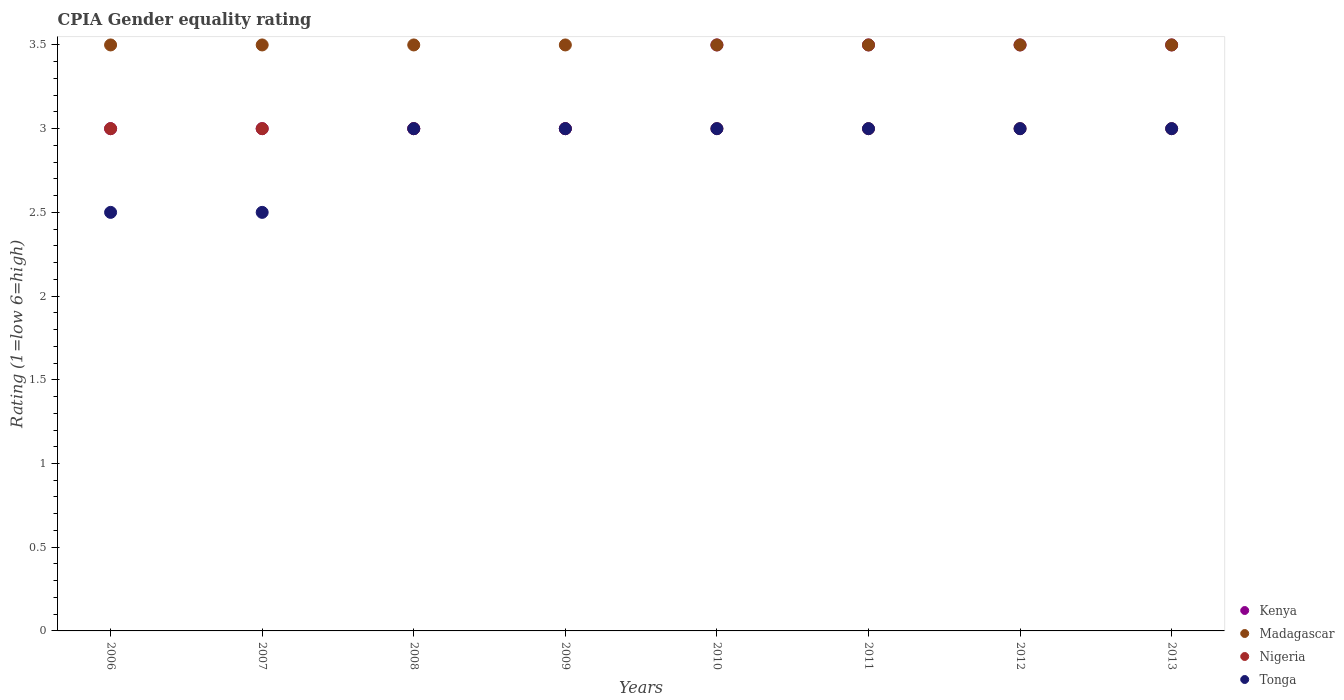How many different coloured dotlines are there?
Give a very brief answer. 4. Across all years, what is the maximum CPIA rating in Tonga?
Offer a very short reply. 3. Across all years, what is the minimum CPIA rating in Nigeria?
Offer a very short reply. 3. In which year was the CPIA rating in Tonga maximum?
Make the answer very short. 2008. What is the total CPIA rating in Tonga in the graph?
Provide a short and direct response. 23. What is the difference between the CPIA rating in Nigeria in 2007 and the CPIA rating in Madagascar in 2009?
Your answer should be compact. -0.5. In the year 2011, what is the difference between the CPIA rating in Nigeria and CPIA rating in Kenya?
Your answer should be very brief. -0.5. In how many years, is the CPIA rating in Kenya greater than 1.2?
Your answer should be very brief. 8. What is the ratio of the CPIA rating in Madagascar in 2011 to that in 2012?
Give a very brief answer. 1. Is the CPIA rating in Tonga in 2009 less than that in 2011?
Provide a succinct answer. No. What is the difference between the highest and the second highest CPIA rating in Kenya?
Offer a terse response. 0. What is the difference between the highest and the lowest CPIA rating in Tonga?
Your answer should be compact. 0.5. Is the sum of the CPIA rating in Tonga in 2006 and 2009 greater than the maximum CPIA rating in Madagascar across all years?
Offer a very short reply. Yes. Is it the case that in every year, the sum of the CPIA rating in Nigeria and CPIA rating in Tonga  is greater than the sum of CPIA rating in Madagascar and CPIA rating in Kenya?
Your answer should be compact. No. Is it the case that in every year, the sum of the CPIA rating in Kenya and CPIA rating in Madagascar  is greater than the CPIA rating in Tonga?
Ensure brevity in your answer.  Yes. Does the CPIA rating in Tonga monotonically increase over the years?
Offer a very short reply. No. What is the difference between two consecutive major ticks on the Y-axis?
Your answer should be compact. 0.5. Where does the legend appear in the graph?
Give a very brief answer. Bottom right. What is the title of the graph?
Provide a short and direct response. CPIA Gender equality rating. What is the label or title of the X-axis?
Provide a succinct answer. Years. What is the label or title of the Y-axis?
Ensure brevity in your answer.  Rating (1=low 6=high). What is the Rating (1=low 6=high) of Kenya in 2006?
Offer a very short reply. 3. What is the Rating (1=low 6=high) of Kenya in 2007?
Keep it short and to the point. 3. What is the Rating (1=low 6=high) in Madagascar in 2007?
Make the answer very short. 3.5. What is the Rating (1=low 6=high) of Nigeria in 2007?
Provide a short and direct response. 3. What is the Rating (1=low 6=high) of Madagascar in 2008?
Offer a very short reply. 3.5. What is the Rating (1=low 6=high) in Nigeria in 2008?
Make the answer very short. 3. What is the Rating (1=low 6=high) in Nigeria in 2009?
Give a very brief answer. 3. What is the Rating (1=low 6=high) in Tonga in 2009?
Your answer should be compact. 3. What is the Rating (1=low 6=high) of Nigeria in 2010?
Provide a short and direct response. 3. What is the Rating (1=low 6=high) of Kenya in 2011?
Give a very brief answer. 3.5. What is the Rating (1=low 6=high) of Tonga in 2011?
Provide a short and direct response. 3. What is the Rating (1=low 6=high) in Kenya in 2013?
Your response must be concise. 3.5. What is the Rating (1=low 6=high) in Nigeria in 2013?
Offer a very short reply. 3. What is the Rating (1=low 6=high) in Tonga in 2013?
Provide a succinct answer. 3. Across all years, what is the maximum Rating (1=low 6=high) in Madagascar?
Keep it short and to the point. 3.5. Across all years, what is the maximum Rating (1=low 6=high) of Tonga?
Keep it short and to the point. 3. Across all years, what is the minimum Rating (1=low 6=high) in Kenya?
Offer a terse response. 3. Across all years, what is the minimum Rating (1=low 6=high) of Madagascar?
Your answer should be compact. 3.5. What is the total Rating (1=low 6=high) in Kenya in the graph?
Offer a very short reply. 26. What is the total Rating (1=low 6=high) in Tonga in the graph?
Your answer should be very brief. 23. What is the difference between the Rating (1=low 6=high) in Madagascar in 2006 and that in 2007?
Make the answer very short. 0. What is the difference between the Rating (1=low 6=high) of Nigeria in 2006 and that in 2007?
Keep it short and to the point. 0. What is the difference between the Rating (1=low 6=high) of Tonga in 2006 and that in 2008?
Provide a short and direct response. -0.5. What is the difference between the Rating (1=low 6=high) of Kenya in 2006 and that in 2009?
Give a very brief answer. 0. What is the difference between the Rating (1=low 6=high) in Nigeria in 2006 and that in 2009?
Offer a terse response. 0. What is the difference between the Rating (1=low 6=high) of Kenya in 2006 and that in 2010?
Make the answer very short. -0.5. What is the difference between the Rating (1=low 6=high) in Madagascar in 2006 and that in 2010?
Ensure brevity in your answer.  0. What is the difference between the Rating (1=low 6=high) of Kenya in 2006 and that in 2011?
Your response must be concise. -0.5. What is the difference between the Rating (1=low 6=high) of Nigeria in 2006 and that in 2011?
Provide a short and direct response. 0. What is the difference between the Rating (1=low 6=high) in Kenya in 2006 and that in 2012?
Give a very brief answer. -0.5. What is the difference between the Rating (1=low 6=high) in Tonga in 2006 and that in 2012?
Keep it short and to the point. -0.5. What is the difference between the Rating (1=low 6=high) of Madagascar in 2006 and that in 2013?
Your answer should be very brief. 0. What is the difference between the Rating (1=low 6=high) of Tonga in 2006 and that in 2013?
Make the answer very short. -0.5. What is the difference between the Rating (1=low 6=high) of Tonga in 2007 and that in 2008?
Give a very brief answer. -0.5. What is the difference between the Rating (1=low 6=high) of Kenya in 2007 and that in 2009?
Give a very brief answer. 0. What is the difference between the Rating (1=low 6=high) in Tonga in 2007 and that in 2009?
Ensure brevity in your answer.  -0.5. What is the difference between the Rating (1=low 6=high) in Nigeria in 2007 and that in 2010?
Offer a terse response. 0. What is the difference between the Rating (1=low 6=high) of Madagascar in 2007 and that in 2011?
Offer a terse response. 0. What is the difference between the Rating (1=low 6=high) in Nigeria in 2007 and that in 2011?
Make the answer very short. 0. What is the difference between the Rating (1=low 6=high) in Tonga in 2007 and that in 2011?
Your answer should be very brief. -0.5. What is the difference between the Rating (1=low 6=high) in Kenya in 2007 and that in 2012?
Ensure brevity in your answer.  -0.5. What is the difference between the Rating (1=low 6=high) of Tonga in 2007 and that in 2013?
Ensure brevity in your answer.  -0.5. What is the difference between the Rating (1=low 6=high) in Kenya in 2008 and that in 2009?
Provide a succinct answer. 0. What is the difference between the Rating (1=low 6=high) of Madagascar in 2008 and that in 2009?
Your response must be concise. 0. What is the difference between the Rating (1=low 6=high) in Nigeria in 2008 and that in 2009?
Ensure brevity in your answer.  0. What is the difference between the Rating (1=low 6=high) in Madagascar in 2008 and that in 2010?
Your response must be concise. 0. What is the difference between the Rating (1=low 6=high) in Tonga in 2008 and that in 2010?
Give a very brief answer. 0. What is the difference between the Rating (1=low 6=high) of Madagascar in 2008 and that in 2011?
Give a very brief answer. 0. What is the difference between the Rating (1=low 6=high) in Nigeria in 2008 and that in 2011?
Offer a very short reply. 0. What is the difference between the Rating (1=low 6=high) of Tonga in 2008 and that in 2011?
Offer a terse response. 0. What is the difference between the Rating (1=low 6=high) of Nigeria in 2008 and that in 2012?
Give a very brief answer. 0. What is the difference between the Rating (1=low 6=high) in Kenya in 2008 and that in 2013?
Make the answer very short. -0.5. What is the difference between the Rating (1=low 6=high) of Madagascar in 2008 and that in 2013?
Offer a very short reply. 0. What is the difference between the Rating (1=low 6=high) in Nigeria in 2008 and that in 2013?
Ensure brevity in your answer.  0. What is the difference between the Rating (1=low 6=high) in Nigeria in 2009 and that in 2010?
Offer a terse response. 0. What is the difference between the Rating (1=low 6=high) in Kenya in 2009 and that in 2011?
Make the answer very short. -0.5. What is the difference between the Rating (1=low 6=high) of Nigeria in 2009 and that in 2012?
Ensure brevity in your answer.  0. What is the difference between the Rating (1=low 6=high) of Tonga in 2009 and that in 2012?
Your answer should be compact. 0. What is the difference between the Rating (1=low 6=high) in Kenya in 2009 and that in 2013?
Ensure brevity in your answer.  -0.5. What is the difference between the Rating (1=low 6=high) of Madagascar in 2009 and that in 2013?
Your answer should be compact. 0. What is the difference between the Rating (1=low 6=high) of Tonga in 2009 and that in 2013?
Provide a short and direct response. 0. What is the difference between the Rating (1=low 6=high) of Nigeria in 2010 and that in 2011?
Provide a succinct answer. 0. What is the difference between the Rating (1=low 6=high) of Madagascar in 2010 and that in 2012?
Your answer should be very brief. 0. What is the difference between the Rating (1=low 6=high) in Nigeria in 2010 and that in 2012?
Your response must be concise. 0. What is the difference between the Rating (1=low 6=high) of Kenya in 2010 and that in 2013?
Make the answer very short. 0. What is the difference between the Rating (1=low 6=high) in Tonga in 2010 and that in 2013?
Give a very brief answer. 0. What is the difference between the Rating (1=low 6=high) of Madagascar in 2011 and that in 2012?
Keep it short and to the point. 0. What is the difference between the Rating (1=low 6=high) in Madagascar in 2011 and that in 2013?
Ensure brevity in your answer.  0. What is the difference between the Rating (1=low 6=high) in Nigeria in 2011 and that in 2013?
Provide a succinct answer. 0. What is the difference between the Rating (1=low 6=high) of Kenya in 2012 and that in 2013?
Provide a short and direct response. 0. What is the difference between the Rating (1=low 6=high) in Tonga in 2012 and that in 2013?
Ensure brevity in your answer.  0. What is the difference between the Rating (1=low 6=high) of Kenya in 2006 and the Rating (1=low 6=high) of Tonga in 2007?
Keep it short and to the point. 0.5. What is the difference between the Rating (1=low 6=high) in Madagascar in 2006 and the Rating (1=low 6=high) in Nigeria in 2007?
Your answer should be compact. 0.5. What is the difference between the Rating (1=low 6=high) in Madagascar in 2006 and the Rating (1=low 6=high) in Tonga in 2007?
Give a very brief answer. 1. What is the difference between the Rating (1=low 6=high) in Nigeria in 2006 and the Rating (1=low 6=high) in Tonga in 2007?
Your answer should be compact. 0.5. What is the difference between the Rating (1=low 6=high) in Kenya in 2006 and the Rating (1=low 6=high) in Madagascar in 2008?
Your answer should be compact. -0.5. What is the difference between the Rating (1=low 6=high) in Kenya in 2006 and the Rating (1=low 6=high) in Nigeria in 2008?
Your answer should be compact. 0. What is the difference between the Rating (1=low 6=high) of Kenya in 2006 and the Rating (1=low 6=high) of Tonga in 2008?
Offer a terse response. 0. What is the difference between the Rating (1=low 6=high) of Madagascar in 2006 and the Rating (1=low 6=high) of Nigeria in 2008?
Ensure brevity in your answer.  0.5. What is the difference between the Rating (1=low 6=high) of Kenya in 2006 and the Rating (1=low 6=high) of Nigeria in 2009?
Your answer should be compact. 0. What is the difference between the Rating (1=low 6=high) in Kenya in 2006 and the Rating (1=low 6=high) in Tonga in 2009?
Provide a short and direct response. 0. What is the difference between the Rating (1=low 6=high) in Kenya in 2006 and the Rating (1=low 6=high) in Tonga in 2010?
Make the answer very short. 0. What is the difference between the Rating (1=low 6=high) in Nigeria in 2006 and the Rating (1=low 6=high) in Tonga in 2010?
Provide a short and direct response. 0. What is the difference between the Rating (1=low 6=high) of Madagascar in 2006 and the Rating (1=low 6=high) of Nigeria in 2011?
Your response must be concise. 0.5. What is the difference between the Rating (1=low 6=high) of Madagascar in 2006 and the Rating (1=low 6=high) of Tonga in 2011?
Provide a short and direct response. 0.5. What is the difference between the Rating (1=low 6=high) in Nigeria in 2006 and the Rating (1=low 6=high) in Tonga in 2011?
Your answer should be very brief. 0. What is the difference between the Rating (1=low 6=high) of Kenya in 2006 and the Rating (1=low 6=high) of Madagascar in 2012?
Give a very brief answer. -0.5. What is the difference between the Rating (1=low 6=high) in Kenya in 2006 and the Rating (1=low 6=high) in Nigeria in 2012?
Ensure brevity in your answer.  0. What is the difference between the Rating (1=low 6=high) of Kenya in 2006 and the Rating (1=low 6=high) of Tonga in 2012?
Ensure brevity in your answer.  0. What is the difference between the Rating (1=low 6=high) in Madagascar in 2006 and the Rating (1=low 6=high) in Nigeria in 2012?
Your answer should be very brief. 0.5. What is the difference between the Rating (1=low 6=high) of Madagascar in 2006 and the Rating (1=low 6=high) of Tonga in 2012?
Ensure brevity in your answer.  0.5. What is the difference between the Rating (1=low 6=high) in Madagascar in 2006 and the Rating (1=low 6=high) in Nigeria in 2013?
Ensure brevity in your answer.  0.5. What is the difference between the Rating (1=low 6=high) in Madagascar in 2006 and the Rating (1=low 6=high) in Tonga in 2013?
Ensure brevity in your answer.  0.5. What is the difference between the Rating (1=low 6=high) in Nigeria in 2006 and the Rating (1=low 6=high) in Tonga in 2013?
Ensure brevity in your answer.  0. What is the difference between the Rating (1=low 6=high) in Kenya in 2007 and the Rating (1=low 6=high) in Madagascar in 2008?
Your answer should be compact. -0.5. What is the difference between the Rating (1=low 6=high) in Kenya in 2007 and the Rating (1=low 6=high) in Nigeria in 2008?
Make the answer very short. 0. What is the difference between the Rating (1=low 6=high) in Madagascar in 2007 and the Rating (1=low 6=high) in Tonga in 2008?
Offer a terse response. 0.5. What is the difference between the Rating (1=low 6=high) of Nigeria in 2007 and the Rating (1=low 6=high) of Tonga in 2008?
Your response must be concise. 0. What is the difference between the Rating (1=low 6=high) in Madagascar in 2007 and the Rating (1=low 6=high) in Tonga in 2009?
Your response must be concise. 0.5. What is the difference between the Rating (1=low 6=high) of Kenya in 2007 and the Rating (1=low 6=high) of Nigeria in 2010?
Offer a terse response. 0. What is the difference between the Rating (1=low 6=high) in Kenya in 2007 and the Rating (1=low 6=high) in Tonga in 2010?
Make the answer very short. 0. What is the difference between the Rating (1=low 6=high) of Nigeria in 2007 and the Rating (1=low 6=high) of Tonga in 2010?
Make the answer very short. 0. What is the difference between the Rating (1=low 6=high) of Kenya in 2007 and the Rating (1=low 6=high) of Madagascar in 2011?
Provide a succinct answer. -0.5. What is the difference between the Rating (1=low 6=high) of Kenya in 2007 and the Rating (1=low 6=high) of Tonga in 2011?
Give a very brief answer. 0. What is the difference between the Rating (1=low 6=high) of Nigeria in 2007 and the Rating (1=low 6=high) of Tonga in 2011?
Offer a very short reply. 0. What is the difference between the Rating (1=low 6=high) in Kenya in 2007 and the Rating (1=low 6=high) in Nigeria in 2012?
Ensure brevity in your answer.  0. What is the difference between the Rating (1=low 6=high) in Nigeria in 2007 and the Rating (1=low 6=high) in Tonga in 2012?
Offer a terse response. 0. What is the difference between the Rating (1=low 6=high) of Kenya in 2007 and the Rating (1=low 6=high) of Nigeria in 2013?
Offer a very short reply. 0. What is the difference between the Rating (1=low 6=high) of Nigeria in 2007 and the Rating (1=low 6=high) of Tonga in 2013?
Make the answer very short. 0. What is the difference between the Rating (1=low 6=high) of Kenya in 2008 and the Rating (1=low 6=high) of Madagascar in 2009?
Ensure brevity in your answer.  -0.5. What is the difference between the Rating (1=low 6=high) of Kenya in 2008 and the Rating (1=low 6=high) of Tonga in 2009?
Provide a succinct answer. 0. What is the difference between the Rating (1=low 6=high) in Nigeria in 2008 and the Rating (1=low 6=high) in Tonga in 2009?
Your response must be concise. 0. What is the difference between the Rating (1=low 6=high) in Kenya in 2008 and the Rating (1=low 6=high) in Nigeria in 2010?
Provide a short and direct response. 0. What is the difference between the Rating (1=low 6=high) of Madagascar in 2008 and the Rating (1=low 6=high) of Nigeria in 2010?
Ensure brevity in your answer.  0.5. What is the difference between the Rating (1=low 6=high) in Nigeria in 2008 and the Rating (1=low 6=high) in Tonga in 2010?
Your response must be concise. 0. What is the difference between the Rating (1=low 6=high) of Kenya in 2008 and the Rating (1=low 6=high) of Nigeria in 2011?
Keep it short and to the point. 0. What is the difference between the Rating (1=low 6=high) in Madagascar in 2008 and the Rating (1=low 6=high) in Nigeria in 2011?
Your answer should be very brief. 0.5. What is the difference between the Rating (1=low 6=high) in Nigeria in 2008 and the Rating (1=low 6=high) in Tonga in 2011?
Your response must be concise. 0. What is the difference between the Rating (1=low 6=high) in Kenya in 2008 and the Rating (1=low 6=high) in Madagascar in 2012?
Your answer should be very brief. -0.5. What is the difference between the Rating (1=low 6=high) of Madagascar in 2008 and the Rating (1=low 6=high) of Tonga in 2012?
Keep it short and to the point. 0.5. What is the difference between the Rating (1=low 6=high) of Nigeria in 2008 and the Rating (1=low 6=high) of Tonga in 2012?
Offer a terse response. 0. What is the difference between the Rating (1=low 6=high) of Kenya in 2008 and the Rating (1=low 6=high) of Nigeria in 2013?
Offer a very short reply. 0. What is the difference between the Rating (1=low 6=high) of Kenya in 2008 and the Rating (1=low 6=high) of Tonga in 2013?
Provide a succinct answer. 0. What is the difference between the Rating (1=low 6=high) in Madagascar in 2008 and the Rating (1=low 6=high) in Tonga in 2013?
Your answer should be compact. 0.5. What is the difference between the Rating (1=low 6=high) of Nigeria in 2008 and the Rating (1=low 6=high) of Tonga in 2013?
Ensure brevity in your answer.  0. What is the difference between the Rating (1=low 6=high) of Kenya in 2009 and the Rating (1=low 6=high) of Nigeria in 2010?
Provide a succinct answer. 0. What is the difference between the Rating (1=low 6=high) in Madagascar in 2009 and the Rating (1=low 6=high) in Nigeria in 2010?
Ensure brevity in your answer.  0.5. What is the difference between the Rating (1=low 6=high) in Kenya in 2009 and the Rating (1=low 6=high) in Nigeria in 2011?
Give a very brief answer. 0. What is the difference between the Rating (1=low 6=high) in Kenya in 2009 and the Rating (1=low 6=high) in Tonga in 2011?
Ensure brevity in your answer.  0. What is the difference between the Rating (1=low 6=high) in Nigeria in 2009 and the Rating (1=low 6=high) in Tonga in 2011?
Provide a short and direct response. 0. What is the difference between the Rating (1=low 6=high) in Kenya in 2009 and the Rating (1=low 6=high) in Nigeria in 2012?
Your answer should be very brief. 0. What is the difference between the Rating (1=low 6=high) in Kenya in 2009 and the Rating (1=low 6=high) in Tonga in 2012?
Ensure brevity in your answer.  0. What is the difference between the Rating (1=low 6=high) of Madagascar in 2009 and the Rating (1=low 6=high) of Tonga in 2012?
Keep it short and to the point. 0.5. What is the difference between the Rating (1=low 6=high) of Nigeria in 2009 and the Rating (1=low 6=high) of Tonga in 2012?
Your answer should be compact. 0. What is the difference between the Rating (1=low 6=high) in Kenya in 2009 and the Rating (1=low 6=high) in Madagascar in 2013?
Offer a very short reply. -0.5. What is the difference between the Rating (1=low 6=high) of Kenya in 2009 and the Rating (1=low 6=high) of Nigeria in 2013?
Your response must be concise. 0. What is the difference between the Rating (1=low 6=high) of Kenya in 2009 and the Rating (1=low 6=high) of Tonga in 2013?
Provide a succinct answer. 0. What is the difference between the Rating (1=low 6=high) of Madagascar in 2009 and the Rating (1=low 6=high) of Nigeria in 2013?
Offer a terse response. 0.5. What is the difference between the Rating (1=low 6=high) in Nigeria in 2009 and the Rating (1=low 6=high) in Tonga in 2013?
Keep it short and to the point. 0. What is the difference between the Rating (1=low 6=high) in Kenya in 2010 and the Rating (1=low 6=high) in Tonga in 2011?
Ensure brevity in your answer.  0.5. What is the difference between the Rating (1=low 6=high) of Madagascar in 2010 and the Rating (1=low 6=high) of Nigeria in 2011?
Offer a very short reply. 0.5. What is the difference between the Rating (1=low 6=high) of Madagascar in 2010 and the Rating (1=low 6=high) of Tonga in 2011?
Offer a very short reply. 0.5. What is the difference between the Rating (1=low 6=high) of Nigeria in 2010 and the Rating (1=low 6=high) of Tonga in 2011?
Ensure brevity in your answer.  0. What is the difference between the Rating (1=low 6=high) in Kenya in 2010 and the Rating (1=low 6=high) in Madagascar in 2012?
Your response must be concise. 0. What is the difference between the Rating (1=low 6=high) of Madagascar in 2010 and the Rating (1=low 6=high) of Tonga in 2012?
Make the answer very short. 0.5. What is the difference between the Rating (1=low 6=high) in Kenya in 2010 and the Rating (1=low 6=high) in Nigeria in 2013?
Your response must be concise. 0.5. What is the difference between the Rating (1=low 6=high) of Kenya in 2010 and the Rating (1=low 6=high) of Tonga in 2013?
Your response must be concise. 0.5. What is the difference between the Rating (1=low 6=high) of Nigeria in 2010 and the Rating (1=low 6=high) of Tonga in 2013?
Give a very brief answer. 0. What is the difference between the Rating (1=low 6=high) in Madagascar in 2011 and the Rating (1=low 6=high) in Tonga in 2012?
Your response must be concise. 0.5. What is the difference between the Rating (1=low 6=high) in Nigeria in 2011 and the Rating (1=low 6=high) in Tonga in 2012?
Your response must be concise. 0. What is the difference between the Rating (1=low 6=high) in Kenya in 2011 and the Rating (1=low 6=high) in Madagascar in 2013?
Provide a succinct answer. 0. What is the difference between the Rating (1=low 6=high) in Kenya in 2011 and the Rating (1=low 6=high) in Nigeria in 2013?
Your answer should be compact. 0.5. What is the difference between the Rating (1=low 6=high) in Madagascar in 2011 and the Rating (1=low 6=high) in Nigeria in 2013?
Your answer should be compact. 0.5. What is the difference between the Rating (1=low 6=high) of Nigeria in 2011 and the Rating (1=low 6=high) of Tonga in 2013?
Offer a very short reply. 0. What is the difference between the Rating (1=low 6=high) of Kenya in 2012 and the Rating (1=low 6=high) of Nigeria in 2013?
Offer a terse response. 0.5. What is the difference between the Rating (1=low 6=high) of Madagascar in 2012 and the Rating (1=low 6=high) of Nigeria in 2013?
Make the answer very short. 0.5. What is the difference between the Rating (1=low 6=high) of Madagascar in 2012 and the Rating (1=low 6=high) of Tonga in 2013?
Give a very brief answer. 0.5. What is the difference between the Rating (1=low 6=high) in Nigeria in 2012 and the Rating (1=low 6=high) in Tonga in 2013?
Offer a terse response. 0. What is the average Rating (1=low 6=high) in Kenya per year?
Provide a succinct answer. 3.25. What is the average Rating (1=low 6=high) in Madagascar per year?
Give a very brief answer. 3.5. What is the average Rating (1=low 6=high) in Tonga per year?
Provide a succinct answer. 2.88. In the year 2006, what is the difference between the Rating (1=low 6=high) in Kenya and Rating (1=low 6=high) in Madagascar?
Keep it short and to the point. -0.5. In the year 2006, what is the difference between the Rating (1=low 6=high) in Kenya and Rating (1=low 6=high) in Nigeria?
Offer a very short reply. 0. In the year 2006, what is the difference between the Rating (1=low 6=high) in Kenya and Rating (1=low 6=high) in Tonga?
Keep it short and to the point. 0.5. In the year 2006, what is the difference between the Rating (1=low 6=high) of Madagascar and Rating (1=low 6=high) of Nigeria?
Give a very brief answer. 0.5. In the year 2007, what is the difference between the Rating (1=low 6=high) of Kenya and Rating (1=low 6=high) of Nigeria?
Your answer should be compact. 0. In the year 2007, what is the difference between the Rating (1=low 6=high) in Madagascar and Rating (1=low 6=high) in Nigeria?
Give a very brief answer. 0.5. In the year 2007, what is the difference between the Rating (1=low 6=high) in Madagascar and Rating (1=low 6=high) in Tonga?
Make the answer very short. 1. In the year 2008, what is the difference between the Rating (1=low 6=high) of Kenya and Rating (1=low 6=high) of Nigeria?
Provide a succinct answer. 0. In the year 2008, what is the difference between the Rating (1=low 6=high) of Kenya and Rating (1=low 6=high) of Tonga?
Make the answer very short. 0. In the year 2008, what is the difference between the Rating (1=low 6=high) in Madagascar and Rating (1=low 6=high) in Nigeria?
Your answer should be very brief. 0.5. In the year 2008, what is the difference between the Rating (1=low 6=high) in Nigeria and Rating (1=low 6=high) in Tonga?
Ensure brevity in your answer.  0. In the year 2009, what is the difference between the Rating (1=low 6=high) of Kenya and Rating (1=low 6=high) of Madagascar?
Your answer should be compact. -0.5. In the year 2009, what is the difference between the Rating (1=low 6=high) of Kenya and Rating (1=low 6=high) of Nigeria?
Provide a short and direct response. 0. In the year 2009, what is the difference between the Rating (1=low 6=high) of Kenya and Rating (1=low 6=high) of Tonga?
Keep it short and to the point. 0. In the year 2009, what is the difference between the Rating (1=low 6=high) of Madagascar and Rating (1=low 6=high) of Nigeria?
Ensure brevity in your answer.  0.5. In the year 2009, what is the difference between the Rating (1=low 6=high) in Madagascar and Rating (1=low 6=high) in Tonga?
Your response must be concise. 0.5. In the year 2010, what is the difference between the Rating (1=low 6=high) in Kenya and Rating (1=low 6=high) in Madagascar?
Offer a very short reply. 0. In the year 2010, what is the difference between the Rating (1=low 6=high) of Kenya and Rating (1=low 6=high) of Tonga?
Keep it short and to the point. 0.5. In the year 2010, what is the difference between the Rating (1=low 6=high) in Nigeria and Rating (1=low 6=high) in Tonga?
Offer a very short reply. 0. In the year 2011, what is the difference between the Rating (1=low 6=high) of Kenya and Rating (1=low 6=high) of Madagascar?
Keep it short and to the point. 0. In the year 2011, what is the difference between the Rating (1=low 6=high) of Madagascar and Rating (1=low 6=high) of Tonga?
Keep it short and to the point. 0.5. In the year 2011, what is the difference between the Rating (1=low 6=high) of Nigeria and Rating (1=low 6=high) of Tonga?
Provide a short and direct response. 0. In the year 2012, what is the difference between the Rating (1=low 6=high) of Kenya and Rating (1=low 6=high) of Nigeria?
Make the answer very short. 0.5. In the year 2012, what is the difference between the Rating (1=low 6=high) of Madagascar and Rating (1=low 6=high) of Nigeria?
Give a very brief answer. 0.5. In the year 2012, what is the difference between the Rating (1=low 6=high) of Nigeria and Rating (1=low 6=high) of Tonga?
Your answer should be compact. 0. In the year 2013, what is the difference between the Rating (1=low 6=high) in Kenya and Rating (1=low 6=high) in Nigeria?
Offer a very short reply. 0.5. In the year 2013, what is the difference between the Rating (1=low 6=high) in Nigeria and Rating (1=low 6=high) in Tonga?
Offer a very short reply. 0. What is the ratio of the Rating (1=low 6=high) in Nigeria in 2006 to that in 2007?
Your answer should be very brief. 1. What is the ratio of the Rating (1=low 6=high) in Kenya in 2006 to that in 2008?
Your response must be concise. 1. What is the ratio of the Rating (1=low 6=high) in Madagascar in 2006 to that in 2008?
Your answer should be compact. 1. What is the ratio of the Rating (1=low 6=high) of Tonga in 2006 to that in 2008?
Offer a very short reply. 0.83. What is the ratio of the Rating (1=low 6=high) in Kenya in 2006 to that in 2009?
Your response must be concise. 1. What is the ratio of the Rating (1=low 6=high) of Tonga in 2006 to that in 2009?
Provide a short and direct response. 0.83. What is the ratio of the Rating (1=low 6=high) in Kenya in 2006 to that in 2010?
Keep it short and to the point. 0.86. What is the ratio of the Rating (1=low 6=high) in Madagascar in 2006 to that in 2010?
Provide a succinct answer. 1. What is the ratio of the Rating (1=low 6=high) in Nigeria in 2006 to that in 2010?
Ensure brevity in your answer.  1. What is the ratio of the Rating (1=low 6=high) of Tonga in 2006 to that in 2011?
Keep it short and to the point. 0.83. What is the ratio of the Rating (1=low 6=high) of Kenya in 2006 to that in 2012?
Your answer should be compact. 0.86. What is the ratio of the Rating (1=low 6=high) of Madagascar in 2006 to that in 2012?
Your answer should be very brief. 1. What is the ratio of the Rating (1=low 6=high) in Nigeria in 2006 to that in 2012?
Ensure brevity in your answer.  1. What is the ratio of the Rating (1=low 6=high) in Kenya in 2006 to that in 2013?
Make the answer very short. 0.86. What is the ratio of the Rating (1=low 6=high) in Nigeria in 2006 to that in 2013?
Your answer should be very brief. 1. What is the ratio of the Rating (1=low 6=high) of Tonga in 2006 to that in 2013?
Provide a short and direct response. 0.83. What is the ratio of the Rating (1=low 6=high) in Kenya in 2007 to that in 2008?
Provide a short and direct response. 1. What is the ratio of the Rating (1=low 6=high) in Nigeria in 2007 to that in 2008?
Provide a succinct answer. 1. What is the ratio of the Rating (1=low 6=high) in Madagascar in 2007 to that in 2009?
Ensure brevity in your answer.  1. What is the ratio of the Rating (1=low 6=high) in Tonga in 2007 to that in 2009?
Keep it short and to the point. 0.83. What is the ratio of the Rating (1=low 6=high) of Kenya in 2007 to that in 2010?
Offer a very short reply. 0.86. What is the ratio of the Rating (1=low 6=high) of Madagascar in 2007 to that in 2010?
Offer a very short reply. 1. What is the ratio of the Rating (1=low 6=high) of Kenya in 2007 to that in 2011?
Your answer should be very brief. 0.86. What is the ratio of the Rating (1=low 6=high) of Nigeria in 2007 to that in 2011?
Your response must be concise. 1. What is the ratio of the Rating (1=low 6=high) in Tonga in 2007 to that in 2011?
Offer a terse response. 0.83. What is the ratio of the Rating (1=low 6=high) in Madagascar in 2007 to that in 2012?
Give a very brief answer. 1. What is the ratio of the Rating (1=low 6=high) in Nigeria in 2007 to that in 2012?
Offer a terse response. 1. What is the ratio of the Rating (1=low 6=high) in Tonga in 2007 to that in 2012?
Keep it short and to the point. 0.83. What is the ratio of the Rating (1=low 6=high) of Madagascar in 2007 to that in 2013?
Your answer should be compact. 1. What is the ratio of the Rating (1=low 6=high) of Tonga in 2007 to that in 2013?
Give a very brief answer. 0.83. What is the ratio of the Rating (1=low 6=high) of Kenya in 2008 to that in 2009?
Offer a very short reply. 1. What is the ratio of the Rating (1=low 6=high) in Madagascar in 2008 to that in 2009?
Make the answer very short. 1. What is the ratio of the Rating (1=low 6=high) in Nigeria in 2008 to that in 2009?
Your answer should be compact. 1. What is the ratio of the Rating (1=low 6=high) in Madagascar in 2008 to that in 2010?
Your response must be concise. 1. What is the ratio of the Rating (1=low 6=high) in Kenya in 2008 to that in 2011?
Provide a short and direct response. 0.86. What is the ratio of the Rating (1=low 6=high) of Nigeria in 2008 to that in 2011?
Give a very brief answer. 1. What is the ratio of the Rating (1=low 6=high) of Tonga in 2008 to that in 2011?
Make the answer very short. 1. What is the ratio of the Rating (1=low 6=high) in Kenya in 2008 to that in 2012?
Ensure brevity in your answer.  0.86. What is the ratio of the Rating (1=low 6=high) of Nigeria in 2008 to that in 2012?
Offer a terse response. 1. What is the ratio of the Rating (1=low 6=high) of Tonga in 2008 to that in 2012?
Make the answer very short. 1. What is the ratio of the Rating (1=low 6=high) of Kenya in 2008 to that in 2013?
Provide a succinct answer. 0.86. What is the ratio of the Rating (1=low 6=high) of Nigeria in 2008 to that in 2013?
Your response must be concise. 1. What is the ratio of the Rating (1=low 6=high) of Kenya in 2009 to that in 2010?
Your answer should be compact. 0.86. What is the ratio of the Rating (1=low 6=high) of Madagascar in 2009 to that in 2010?
Make the answer very short. 1. What is the ratio of the Rating (1=low 6=high) in Nigeria in 2009 to that in 2010?
Provide a short and direct response. 1. What is the ratio of the Rating (1=low 6=high) of Tonga in 2009 to that in 2010?
Give a very brief answer. 1. What is the ratio of the Rating (1=low 6=high) of Madagascar in 2009 to that in 2011?
Provide a succinct answer. 1. What is the ratio of the Rating (1=low 6=high) in Nigeria in 2009 to that in 2011?
Your answer should be compact. 1. What is the ratio of the Rating (1=low 6=high) in Tonga in 2009 to that in 2011?
Make the answer very short. 1. What is the ratio of the Rating (1=low 6=high) in Madagascar in 2009 to that in 2012?
Keep it short and to the point. 1. What is the ratio of the Rating (1=low 6=high) of Tonga in 2009 to that in 2012?
Your answer should be compact. 1. What is the ratio of the Rating (1=low 6=high) of Tonga in 2009 to that in 2013?
Keep it short and to the point. 1. What is the ratio of the Rating (1=low 6=high) in Nigeria in 2010 to that in 2012?
Offer a very short reply. 1. What is the ratio of the Rating (1=low 6=high) in Kenya in 2010 to that in 2013?
Make the answer very short. 1. What is the ratio of the Rating (1=low 6=high) of Madagascar in 2010 to that in 2013?
Offer a very short reply. 1. What is the ratio of the Rating (1=low 6=high) in Nigeria in 2011 to that in 2012?
Ensure brevity in your answer.  1. What is the ratio of the Rating (1=low 6=high) in Tonga in 2011 to that in 2012?
Ensure brevity in your answer.  1. What is the ratio of the Rating (1=low 6=high) of Kenya in 2011 to that in 2013?
Your answer should be compact. 1. What is the ratio of the Rating (1=low 6=high) in Madagascar in 2011 to that in 2013?
Provide a short and direct response. 1. What is the ratio of the Rating (1=low 6=high) of Nigeria in 2011 to that in 2013?
Your answer should be very brief. 1. What is the ratio of the Rating (1=low 6=high) of Madagascar in 2012 to that in 2013?
Keep it short and to the point. 1. What is the ratio of the Rating (1=low 6=high) in Tonga in 2012 to that in 2013?
Make the answer very short. 1. What is the difference between the highest and the second highest Rating (1=low 6=high) in Kenya?
Offer a terse response. 0. What is the difference between the highest and the second highest Rating (1=low 6=high) in Madagascar?
Give a very brief answer. 0. What is the difference between the highest and the lowest Rating (1=low 6=high) of Kenya?
Provide a short and direct response. 0.5. What is the difference between the highest and the lowest Rating (1=low 6=high) in Madagascar?
Offer a terse response. 0. What is the difference between the highest and the lowest Rating (1=low 6=high) in Tonga?
Ensure brevity in your answer.  0.5. 